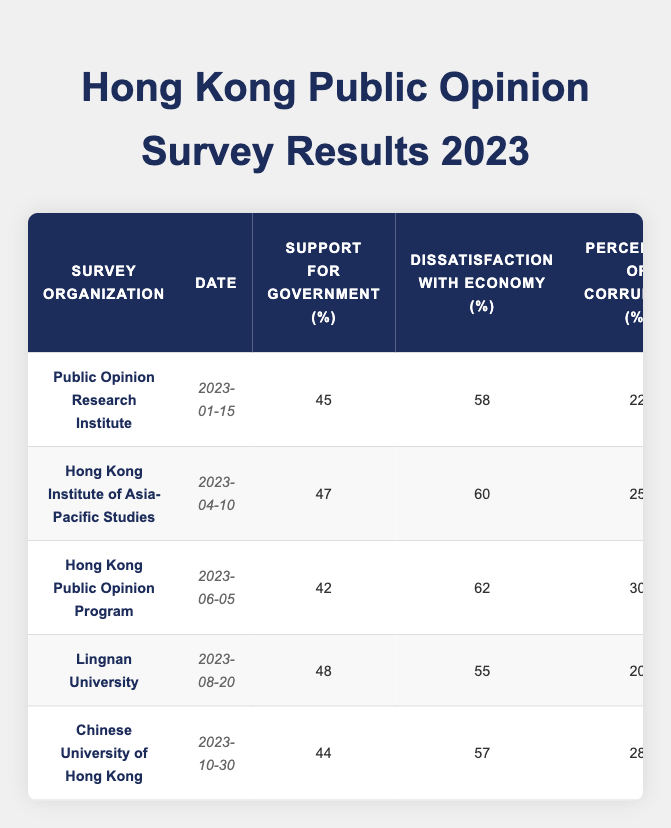What is the highest level of support for government recorded in the surveys? The highest value in the "Support for Government" column is 48%, noted in the survey by Lingnan University on August 20, 2023.
Answer: 48% What is the date of the survey with the lowest approval rating of the Chief Executive? The minimum approval rating is 32%, which corresponds to the survey conducted on June 5, 2023, by the Hong Kong Public Opinion Program.
Answer: June 5, 2023 Is there a trend in the concern for political freedom over the surveyed months? To analyze the trend, observe the values in the "Concern for Political Freedom" column: 65, 70, 68, 64, and 69. The values fluctuate, indicating no clear upward or downward trend.
Answer: No clear trend What was the average dissatisfaction with the economy across the surveys? The dissatisfaction values are 58, 60, 62, 55, and 57. Summing them gives 302, and dividing by 5 results in an average dissatisfaction of 60.4%.
Answer: 60.4% What is the difference between the highest and lowest perception of corruption reported? The highest perception of corruption is 30% (June 5, 2023) and the lowest is 20% (August 20, 2023). The difference is 30 - 20 = 10%.
Answer: 10% Which survey organization reported the lowest support for the National Security Law? The lowest support was reported by the Hong Kong Public Opinion Program with 37% on June 5, 2023.
Answer: Hong Kong Public Opinion Program How does the trust in the legal system compare between the surveys? The trust values are 40, 38, 35, 42, and 37. The range shows that Lingnan University had the highest trust at 42% while the Hong Kong Public Opinion Program had the lowest at 35%, indicating variability across surveys.
Answer: 42% high, 35% low What percentage of respondents expressed support for democracy in the April survey? The April survey conducted by the Hong Kong Institute of Asia-Pacific Studies indicates that 72% of respondents expressed support for democracy.
Answer: 72% Did any survey show an increase in support for the government compared to the previous survey? Yes, comparing surveys: April's 47% increased to August's 48%.
Answer: Yes Which organization had the highest concern for political freedom? The concern for political freedom peaked at 70% according to the survey by the Hong Kong Institute of Asia-Pacific Studies on April 10, 2023.
Answer: 70% 